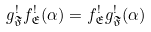Convert formula to latex. <formula><loc_0><loc_0><loc_500><loc_500>g ^ { ! } _ { \mathfrak { F } } f ^ { ! } _ { \mathfrak { E } } ( \alpha ) = f ^ { ! } _ { \mathfrak { E } } g ^ { ! } _ { \mathfrak { F } } ( \alpha )</formula> 